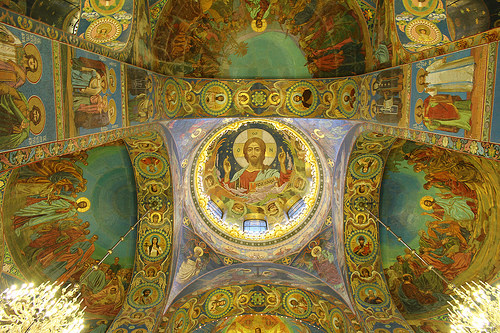<image>
Can you confirm if the icon is on the ceiling? Yes. Looking at the image, I can see the icon is positioned on top of the ceiling, with the ceiling providing support. 